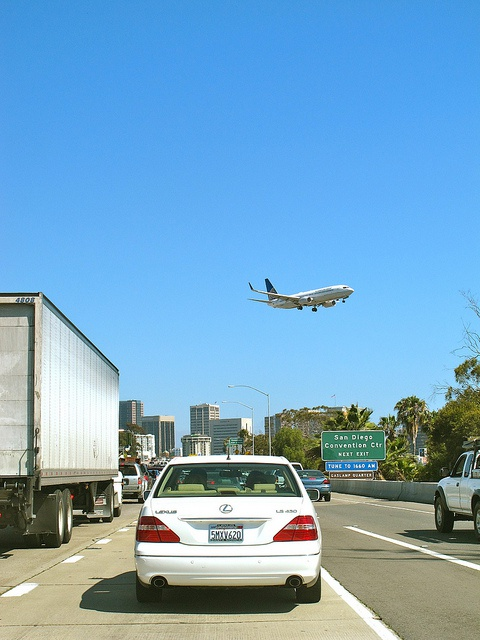Describe the objects in this image and their specific colors. I can see truck in gray, white, black, and darkgray tones, car in gray, white, black, darkgray, and teal tones, truck in gray, black, darkgray, and lightblue tones, airplane in gray, darkgray, and white tones, and car in gray, black, darkgray, and white tones in this image. 